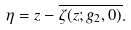Convert formula to latex. <formula><loc_0><loc_0><loc_500><loc_500>\eta = z - \overline { \zeta ( z ; g _ { 2 } , 0 ) } .</formula> 